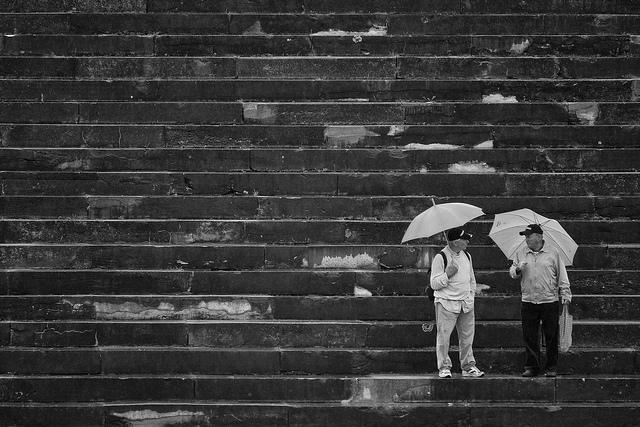How many people are in the picture?
Give a very brief answer. 2. How many sheep are there?
Give a very brief answer. 0. 